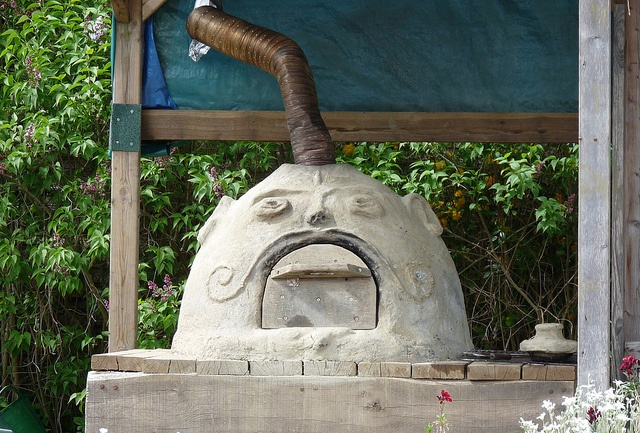Describe the objects in this image and their specific colors. I can see a oven in black, darkgray, ivory, and gray tones in this image. 